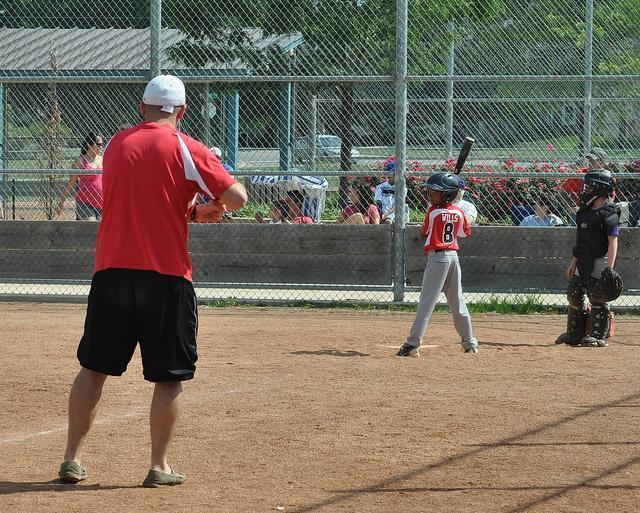How many people are visible?
Give a very brief answer. 4. How many people are on the boat not at the dock?
Give a very brief answer. 0. 